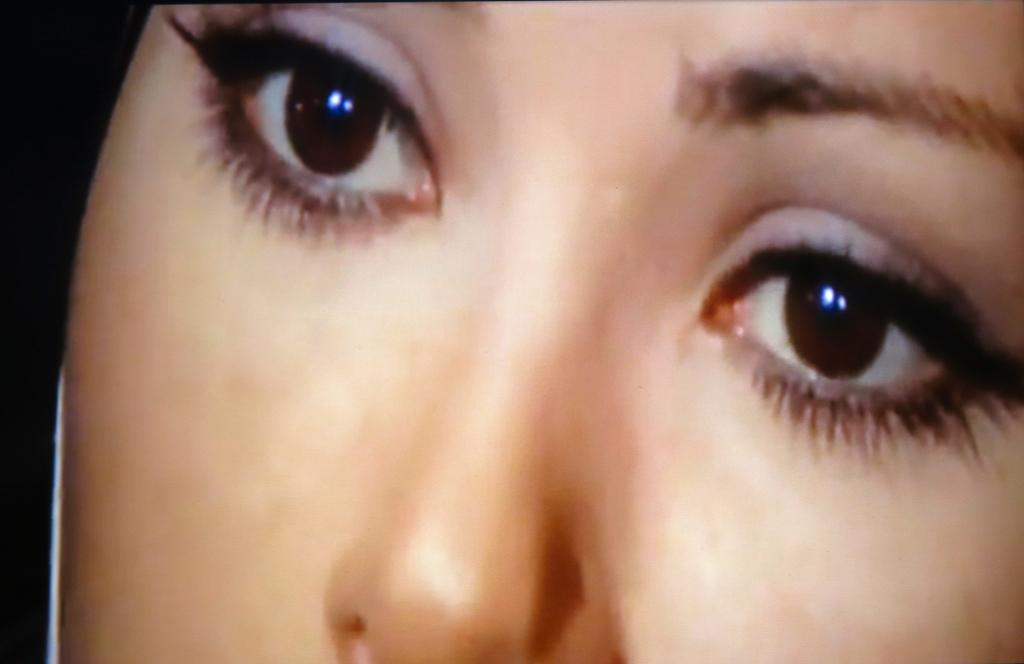What is the main subject of the image? There is a person's face in the image. What facial features can be seen in the image? The person's eyes and nose are visible in the image. How is the lighting in the image? The left side of the image is dark. What type of kettle is boiling on the roof in the image? There is no kettle or roof present in the image; it features a person's face with visible eyes and nose. 